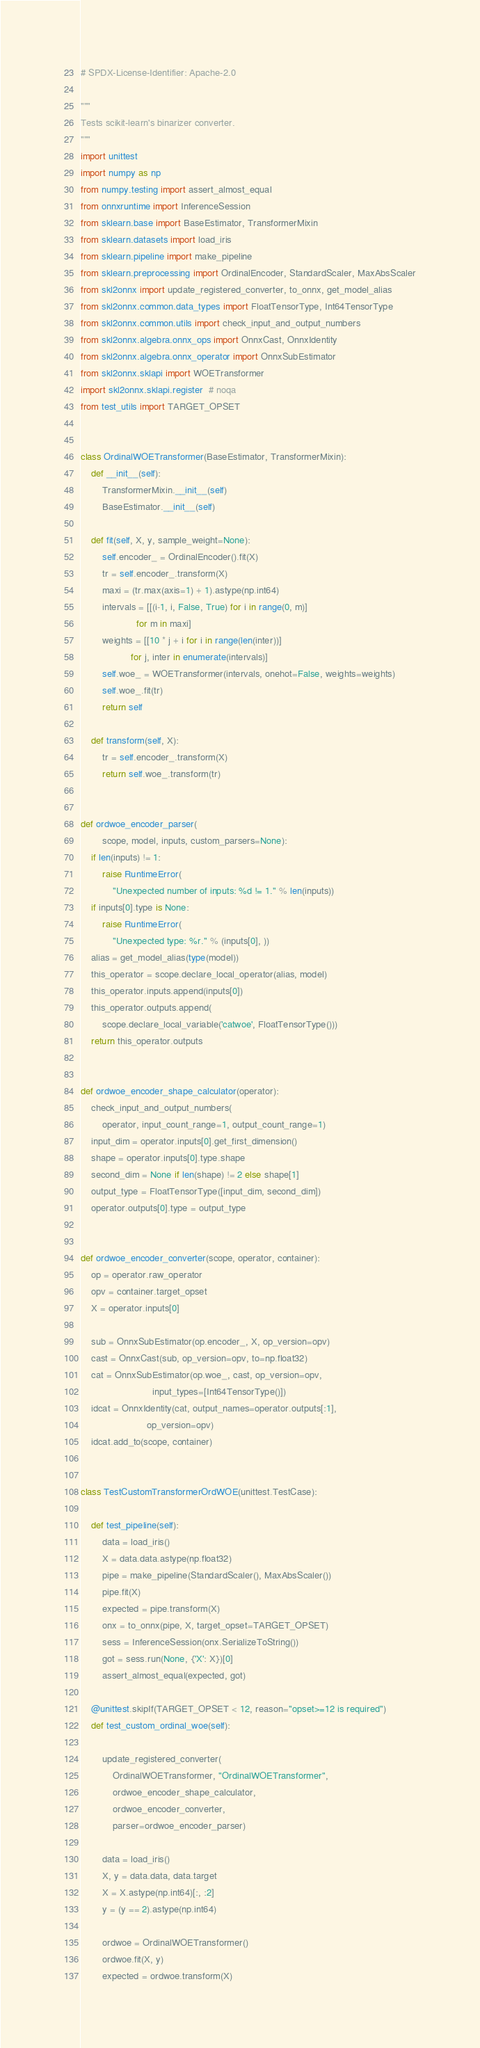<code> <loc_0><loc_0><loc_500><loc_500><_Python_># SPDX-License-Identifier: Apache-2.0

"""
Tests scikit-learn's binarizer converter.
"""
import unittest
import numpy as np
from numpy.testing import assert_almost_equal
from onnxruntime import InferenceSession
from sklearn.base import BaseEstimator, TransformerMixin
from sklearn.datasets import load_iris
from sklearn.pipeline import make_pipeline
from sklearn.preprocessing import OrdinalEncoder, StandardScaler, MaxAbsScaler
from skl2onnx import update_registered_converter, to_onnx, get_model_alias
from skl2onnx.common.data_types import FloatTensorType, Int64TensorType
from skl2onnx.common.utils import check_input_and_output_numbers
from skl2onnx.algebra.onnx_ops import OnnxCast, OnnxIdentity
from skl2onnx.algebra.onnx_operator import OnnxSubEstimator
from skl2onnx.sklapi import WOETransformer
import skl2onnx.sklapi.register  # noqa
from test_utils import TARGET_OPSET


class OrdinalWOETransformer(BaseEstimator, TransformerMixin):
    def __init__(self):
        TransformerMixin.__init__(self)
        BaseEstimator.__init__(self)

    def fit(self, X, y, sample_weight=None):
        self.encoder_ = OrdinalEncoder().fit(X)
        tr = self.encoder_.transform(X)
        maxi = (tr.max(axis=1) + 1).astype(np.int64)
        intervals = [[(i-1, i, False, True) for i in range(0, m)]
                     for m in maxi]
        weights = [[10 * j + i for i in range(len(inter))]
                   for j, inter in enumerate(intervals)]
        self.woe_ = WOETransformer(intervals, onehot=False, weights=weights)
        self.woe_.fit(tr)
        return self

    def transform(self, X):
        tr = self.encoder_.transform(X)
        return self.woe_.transform(tr)


def ordwoe_encoder_parser(
        scope, model, inputs, custom_parsers=None):
    if len(inputs) != 1:
        raise RuntimeError(
            "Unexpected number of inputs: %d != 1." % len(inputs))
    if inputs[0].type is None:
        raise RuntimeError(
            "Unexpected type: %r." % (inputs[0], ))
    alias = get_model_alias(type(model))
    this_operator = scope.declare_local_operator(alias, model)
    this_operator.inputs.append(inputs[0])
    this_operator.outputs.append(
        scope.declare_local_variable('catwoe', FloatTensorType()))
    return this_operator.outputs


def ordwoe_encoder_shape_calculator(operator):
    check_input_and_output_numbers(
        operator, input_count_range=1, output_count_range=1)
    input_dim = operator.inputs[0].get_first_dimension()
    shape = operator.inputs[0].type.shape
    second_dim = None if len(shape) != 2 else shape[1]
    output_type = FloatTensorType([input_dim, second_dim])
    operator.outputs[0].type = output_type


def ordwoe_encoder_converter(scope, operator, container):
    op = operator.raw_operator
    opv = container.target_opset
    X = operator.inputs[0]

    sub = OnnxSubEstimator(op.encoder_, X, op_version=opv)
    cast = OnnxCast(sub, op_version=opv, to=np.float32)
    cat = OnnxSubEstimator(op.woe_, cast, op_version=opv,
                           input_types=[Int64TensorType()])
    idcat = OnnxIdentity(cat, output_names=operator.outputs[:1],
                         op_version=opv)
    idcat.add_to(scope, container)


class TestCustomTransformerOrdWOE(unittest.TestCase):

    def test_pipeline(self):
        data = load_iris()
        X = data.data.astype(np.float32)
        pipe = make_pipeline(StandardScaler(), MaxAbsScaler())
        pipe.fit(X)
        expected = pipe.transform(X)
        onx = to_onnx(pipe, X, target_opset=TARGET_OPSET)
        sess = InferenceSession(onx.SerializeToString())
        got = sess.run(None, {'X': X})[0]
        assert_almost_equal(expected, got)

    @unittest.skipIf(TARGET_OPSET < 12, reason="opset>=12 is required")
    def test_custom_ordinal_woe(self):

        update_registered_converter(
            OrdinalWOETransformer, "OrdinalWOETransformer",
            ordwoe_encoder_shape_calculator,
            ordwoe_encoder_converter,
            parser=ordwoe_encoder_parser)

        data = load_iris()
        X, y = data.data, data.target
        X = X.astype(np.int64)[:, :2]
        y = (y == 2).astype(np.int64)

        ordwoe = OrdinalWOETransformer()
        ordwoe.fit(X, y)
        expected = ordwoe.transform(X)
</code> 